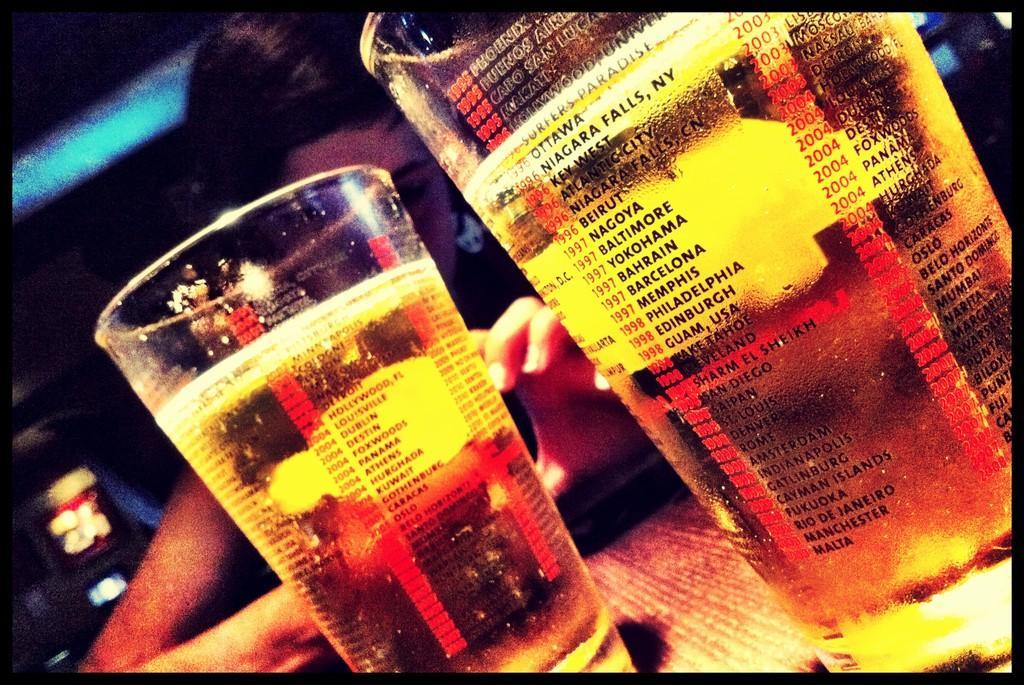Please provide a concise description of this image. There are two glasses in the foreground area of the image and there are lights and a person in the background area. 